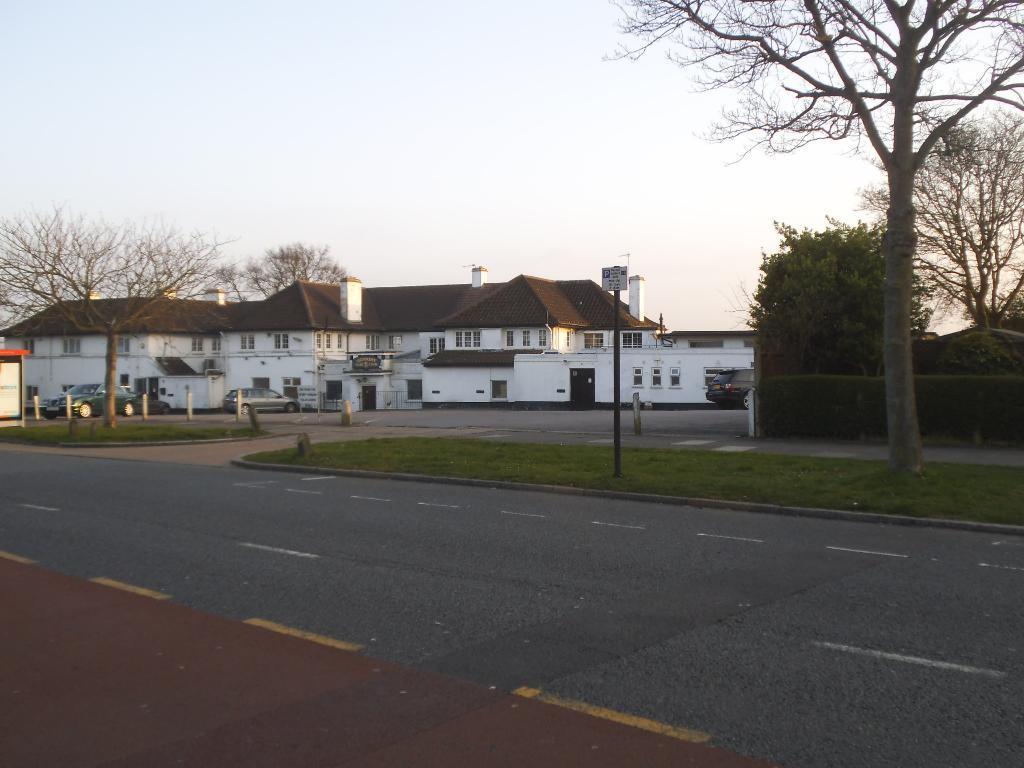Please provide a concise description of this image. In this image we can see road, pole, board, grass, cars, planets, houses, and trees. In the background there is sky. 